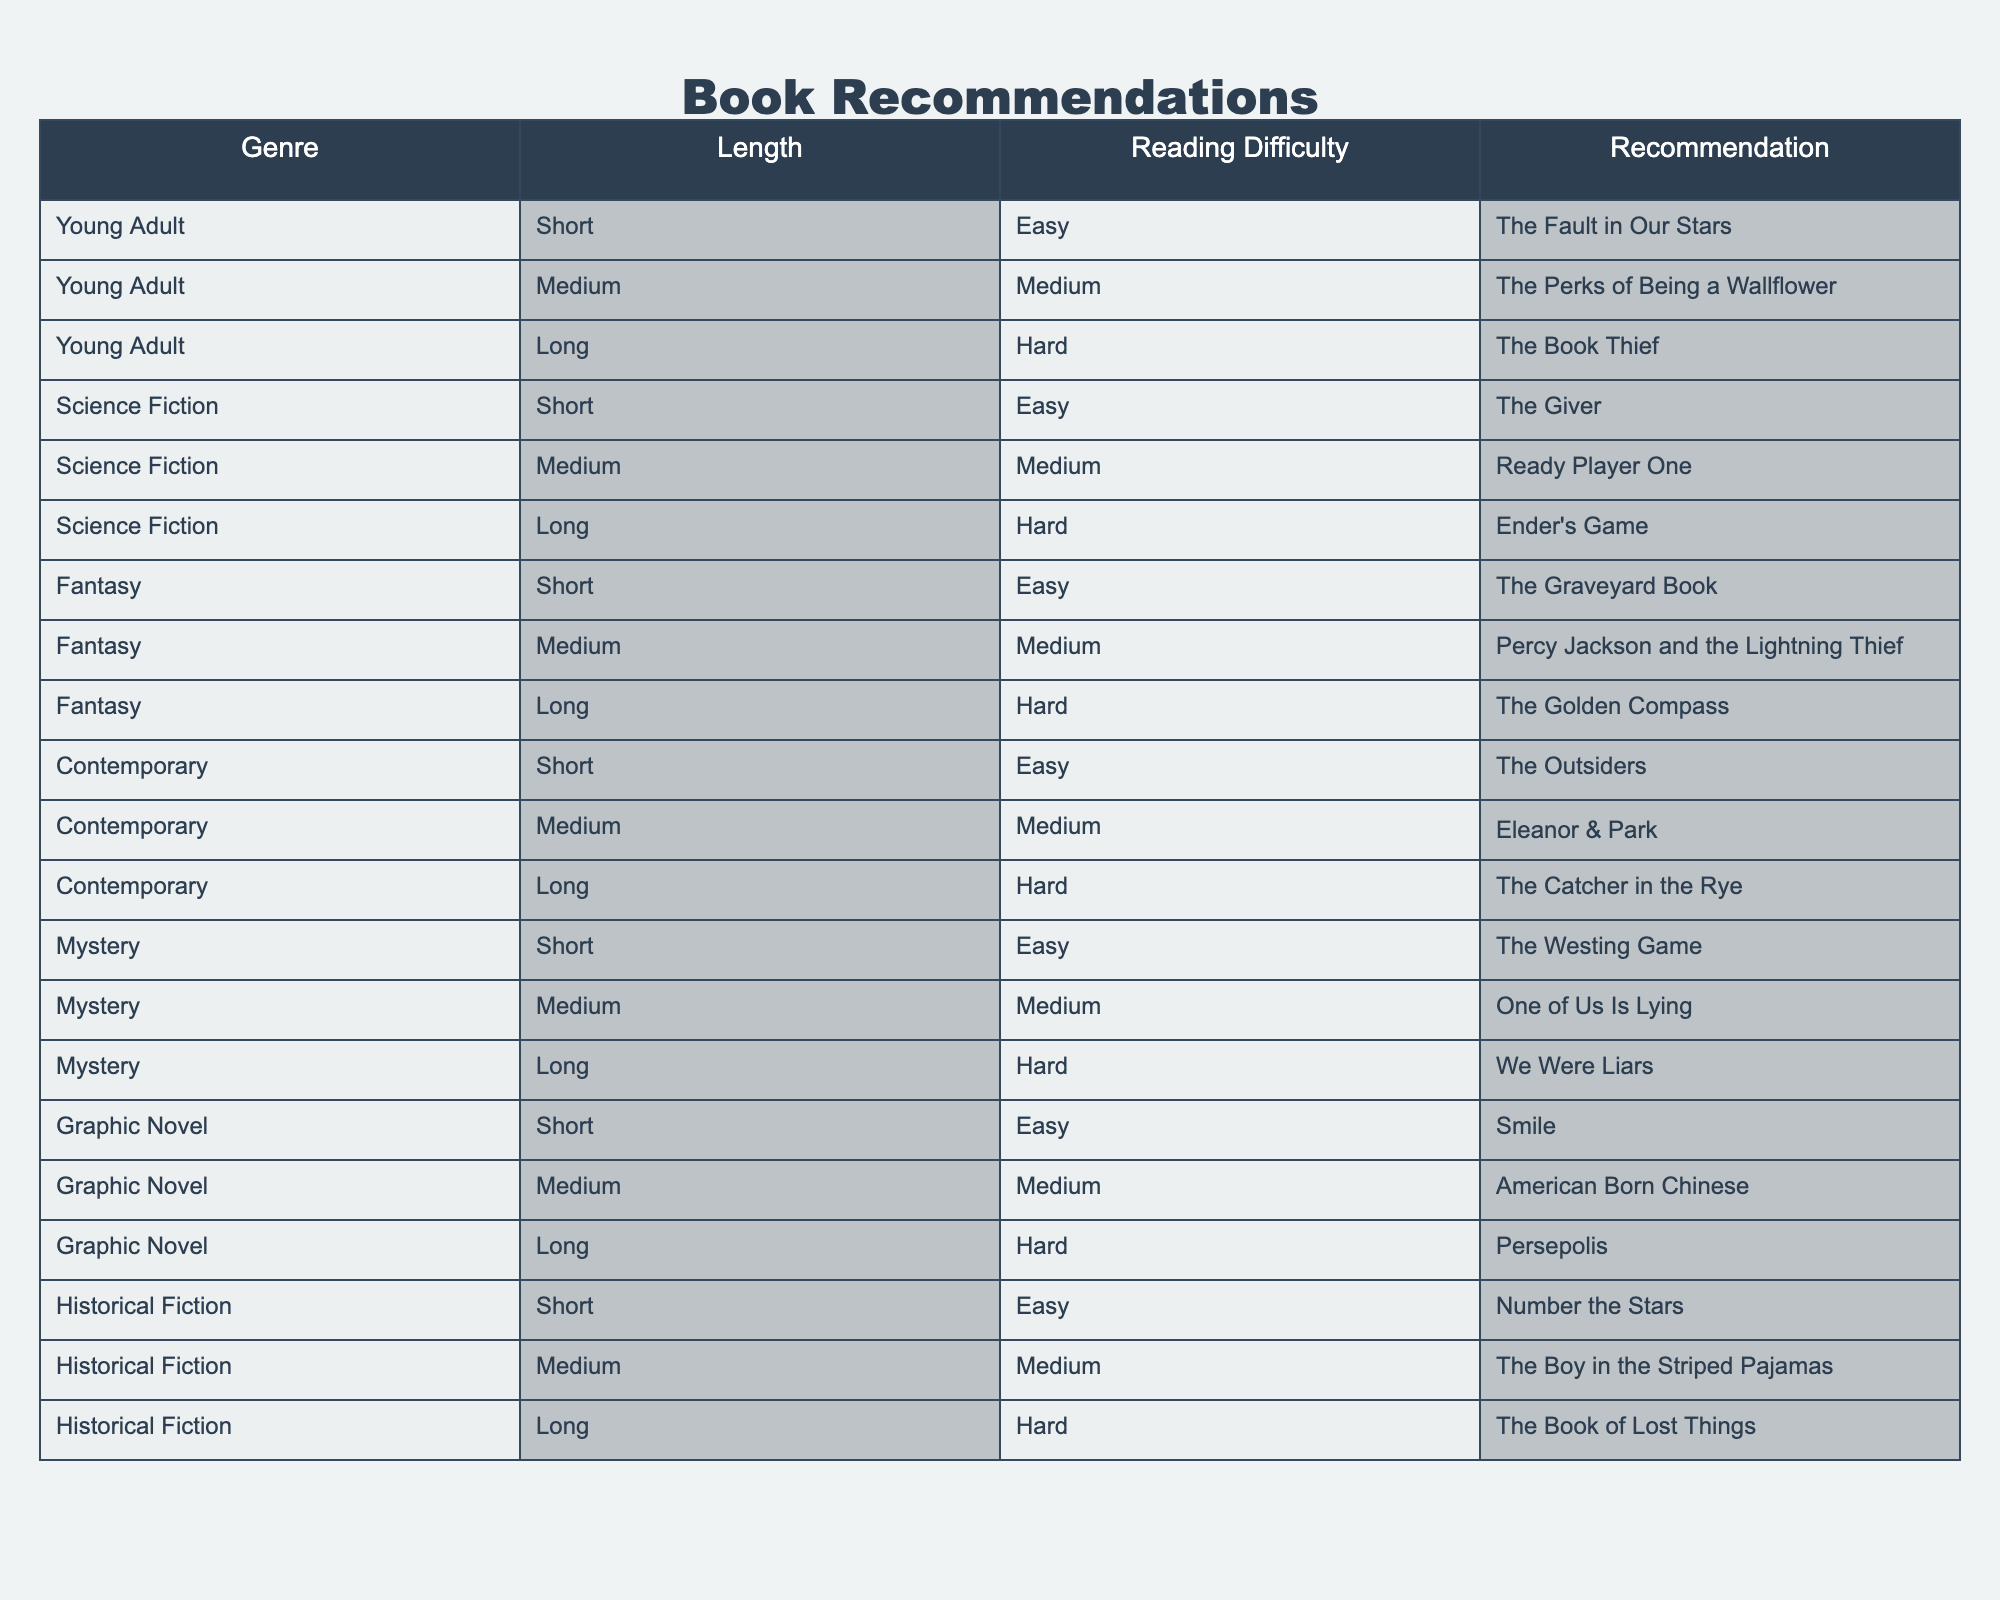What is a recommended book from the Young Adult genre that is easy to read? By looking at the table, I can see that under the Young Adult genre and with an easy reading difficulty, the recommended book is "The Fault in Our Stars."
Answer: The Fault in Our Stars Which genre has the book "Ender's Game" and what is its reading difficulty? The table shows that "Ender's Game" is categorized under the Science Fiction genre, and its reading difficulty is labeled as hard.
Answer: Science Fiction, Hard How many Medium length books are there in the Fantasy genre? Referring to the table, I see one book titled "Percy Jackson and the Lightning Thief" that falls under the Fantasy genre and has a Medium length. Therefore, there is only one.
Answer: 1 Are there any Short length books in the Mystery genre that are easy to read? The table indicates that "The Westing Game" is a Short length book in the Mystery genre, and it has an easy reading difficulty, which means the answer is yes.
Answer: Yes What is the average reading difficulty of Long length books? To find the average reading difficulty of Long length books, we first note the books in that category: "The Book Thief" (Hard), "Ender's Game" (Hard), "The Golden Compass" (Hard), "The Catcher in the Rye" (Hard), "We Were Liars" (Hard), "Persepolis" (Hard), and "The Book of Lost Things" (Hard). All are labeled as Hard, so the average is Hard.
Answer: Hard 